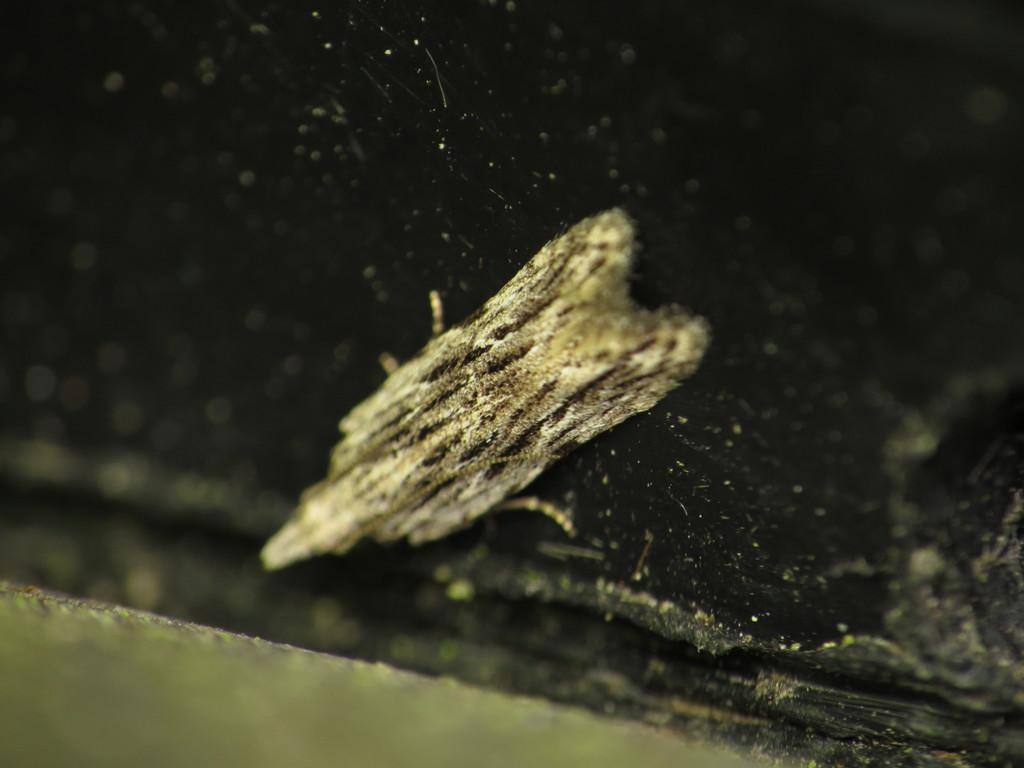What type of creature can be seen in the image? There is an insect in the image. What type of pollution is depicted in the image? There is no pollution depicted in the image; it features an insect. How does the wave affect the insect in the image? There is no wave present in the image, so its effect on the insect cannot be determined. 